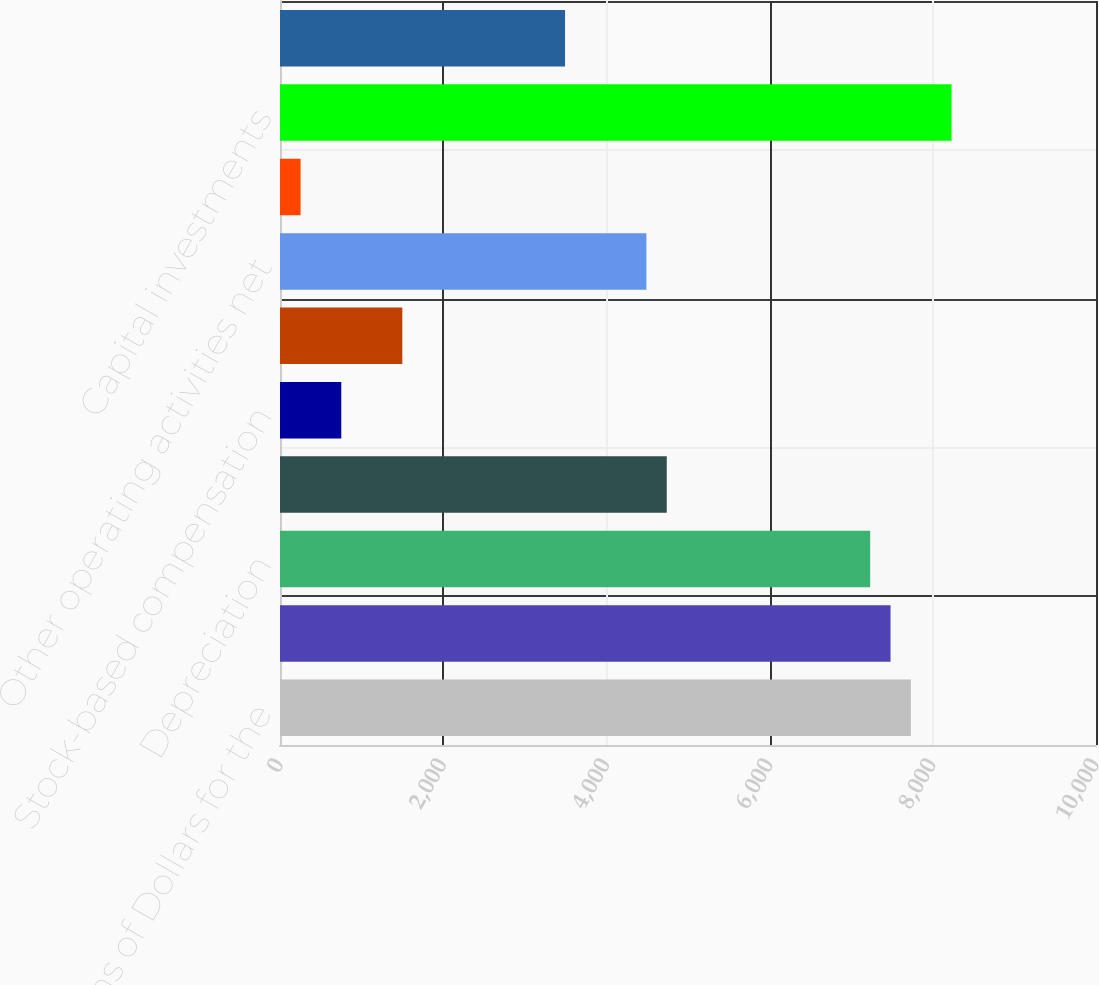<chart> <loc_0><loc_0><loc_500><loc_500><bar_chart><fcel>Millions of Dollars for the<fcel>Net income<fcel>Depreciation<fcel>Deferred income taxes and<fcel>Stock-based compensation<fcel>Net gain from asset sales<fcel>Other operating activities net<fcel>Changes in current assets and<fcel>Capital investments<fcel>Proceeds from asset sales<nl><fcel>7731.3<fcel>7482<fcel>7232.7<fcel>4739.7<fcel>750.9<fcel>1498.8<fcel>4490.4<fcel>252.3<fcel>8229.9<fcel>3493.2<nl></chart> 